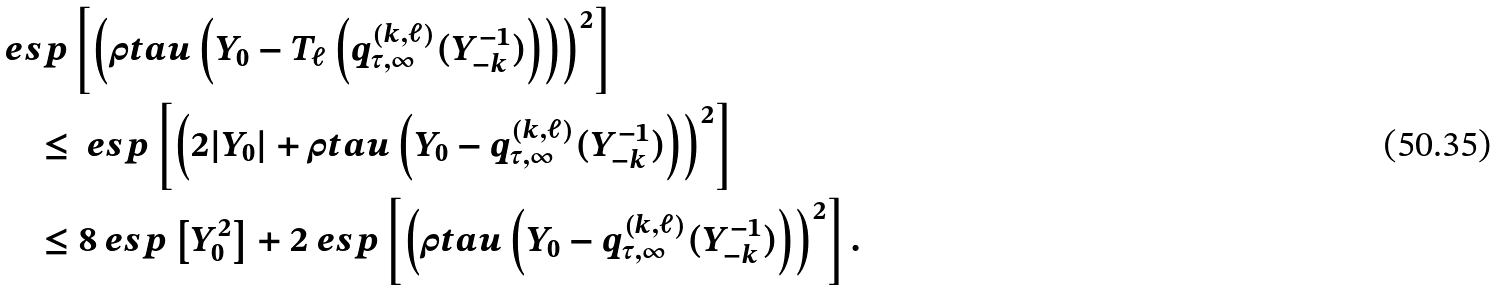<formula> <loc_0><loc_0><loc_500><loc_500>& \ e s p \left [ \left ( \rho t a u \left ( Y _ { 0 } - T _ { \ell } \left ( q _ { \tau , \infty } ^ { ( k , \ell ) } ( Y _ { - k } ^ { - 1 } ) \right ) \right ) \right ) ^ { 2 } \right ] \\ & \quad \leq \ e s p \left [ \left ( 2 | Y _ { 0 } | + \rho t a u \left ( Y _ { 0 } - q _ { \tau , \infty } ^ { ( k , \ell ) } ( Y _ { - k } ^ { - 1 } ) \right ) \right ) ^ { 2 } \right ] \\ & \quad \leq 8 \ e s p \left [ Y _ { 0 } ^ { 2 } \right ] + 2 \ e s p \left [ \left ( \rho t a u \left ( Y _ { 0 } - q _ { \tau , \infty } ^ { ( k , \ell ) } ( Y _ { - k } ^ { - 1 } ) \right ) \right ) ^ { 2 } \right ] .</formula> 